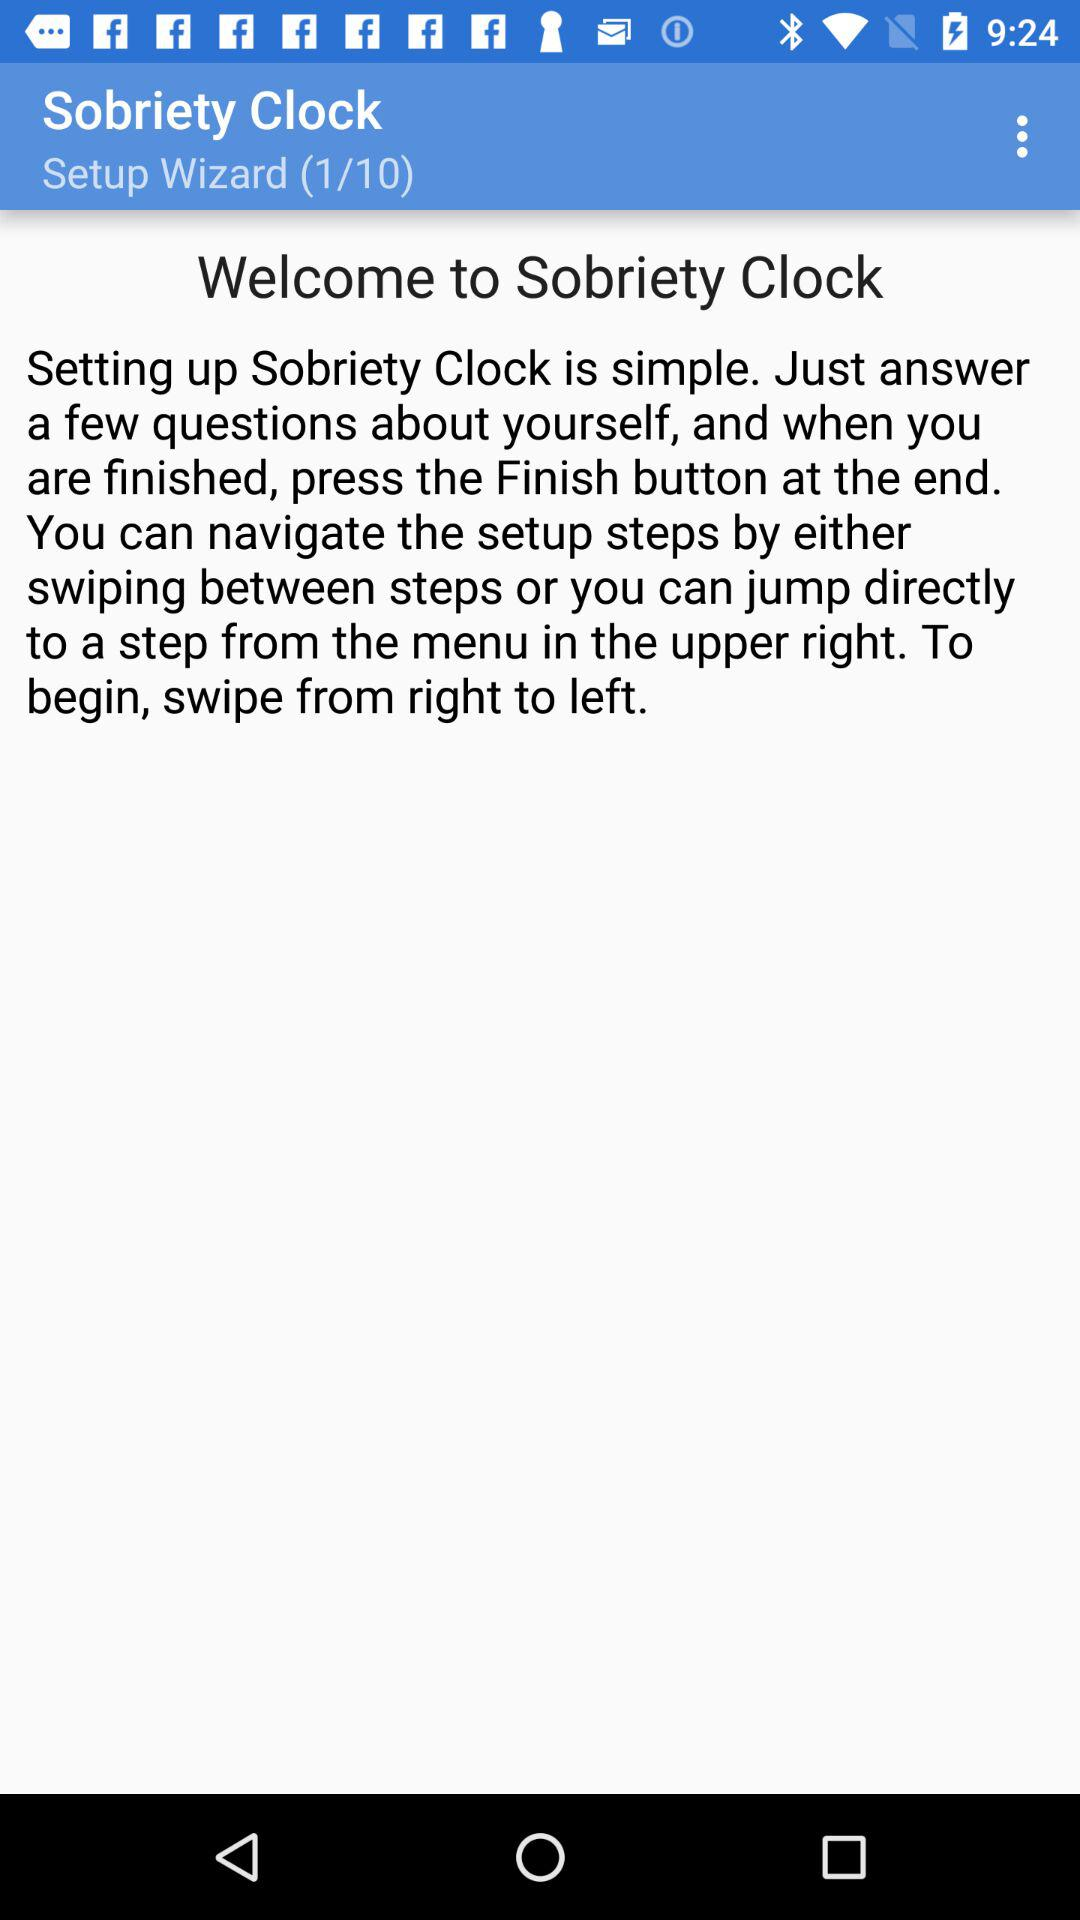How many steps are there in the setup wizard?
Answer the question using a single word or phrase. 10 